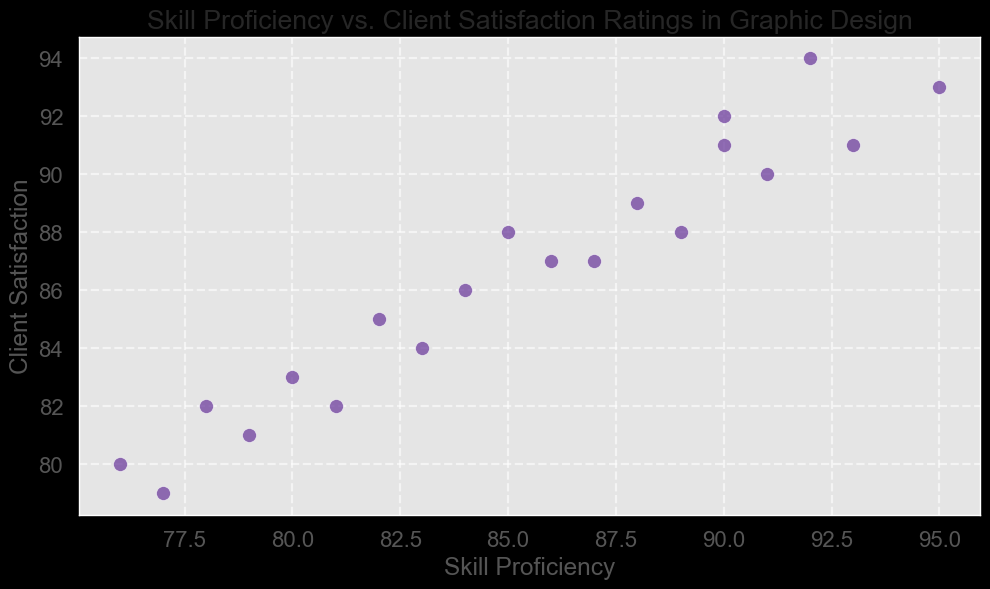What's the skill proficiency level associated with the highest client satisfaction rating? To determine the skill proficiency level that corresponds to the highest client satisfaction rating, locate the point with the highest vertical position (client satisfaction) and read its horizontal value (skill proficiency). The highest client satisfaction rating is 94, at a skill proficiency of 92.
Answer: 92 What is the average of the client satisfaction ratings for skill proficiency levels in the 85-90 range? Identify the points with skill proficiency between 85 and 90, which are: (86, 87), (87, 87), (88, 89). Averaging 87, 87, and 89 gives (87 + 87 + 89) / 3 = 87.67.
Answer: 87.67 Is there any skill proficiency level where the client satisfaction rating is equal to the skill proficiency? Compare each data point where the two values are the same. In this dataset, (87, 87) and (89, 89) have equal values.
Answer: Yes What is the difference in client satisfaction ratings between the maximum and minimum skill proficiency levels? Identify the points with the highest (95, 93) and lowest (76, 80) skill proficiency levels and calculate the difference in their client satisfaction ratings: 93 - 80 = 13.
Answer: 13 Are there more data points above or below the line y = x (where client satisfaction equals skill proficiency)? Count the points with client satisfaction greater than skill proficiency (above y = x) and less than skill proficiency (below y = x). The points above are: 90, 92; 85, 88; 78, 82; 82, 85; 95, 93; 88, 89; 80, 83; 76, 80; 91, 90; 84, 86; 79, 81; 92, 94 while the points below are: 93, 91; 83, 84; 77, 79. There are 12 above and 3 below.
Answer: More above What is the median client satisfaction rating? Arrange the client satisfaction ratings in ascending order and find the middle value: (79, 80, 81, 82, 82, 83, 84, 85, 86, 87, 87, 87, 88, 88, 89, 90, 91, 92, 93, 94). The median is the average of the 10th and 11th values: (87+87)/2 = 87.
Answer: 87 Which data point has the smallest difference between skill proficiency and client satisfaction rating? Calculate the absolute difference for each point and find the smallest: (90-92=2), (85-88=3), (78-82=4), (82-85=3), (95-93=2), (88-89=1), (80-83=3), (76-80=4), (87-87=0), (91-90=1), (84-86=2), (79-81=2), (92-94=2), (83-84=1), (77-79=2), (93-91=2), (89-88=1), (81-82=1), (90-91=1), (86-87=1). The smallest difference is 0 at (87, 87).
Answer: (87, 87) What is the client satisfaction rating for the second-highest skill proficiency level? Identify the second-highest skill proficiency level (93) and find the corresponding client satisfaction rating (91).
Answer: 91 